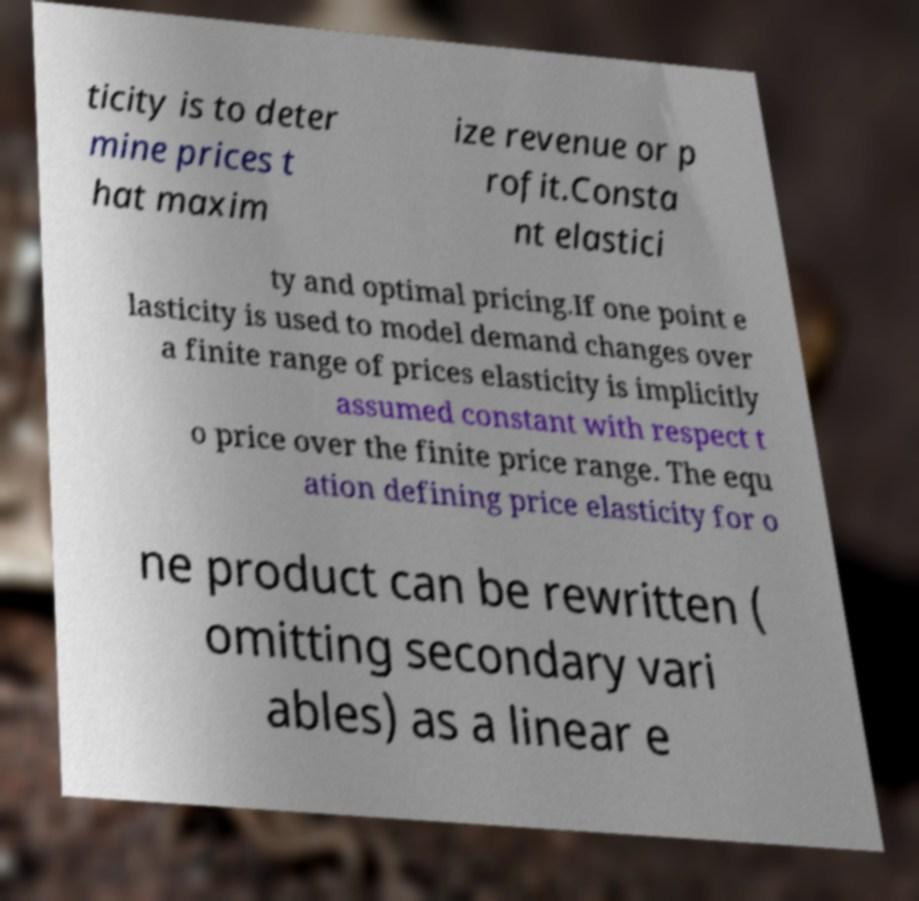I need the written content from this picture converted into text. Can you do that? ticity is to deter mine prices t hat maxim ize revenue or p rofit.Consta nt elastici ty and optimal pricing.If one point e lasticity is used to model demand changes over a finite range of prices elasticity is implicitly assumed constant with respect t o price over the finite price range. The equ ation defining price elasticity for o ne product can be rewritten ( omitting secondary vari ables) as a linear e 